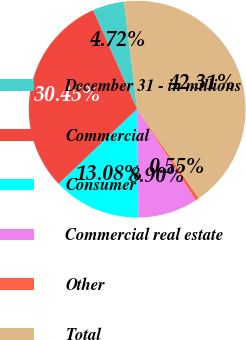Convert chart to OTSL. <chart><loc_0><loc_0><loc_500><loc_500><pie_chart><fcel>December 31 - in millions<fcel>Commercial<fcel>Consumer<fcel>Commercial real estate<fcel>Other<fcel>Total<nl><fcel>4.72%<fcel>30.45%<fcel>13.08%<fcel>8.9%<fcel>0.55%<fcel>42.31%<nl></chart> 